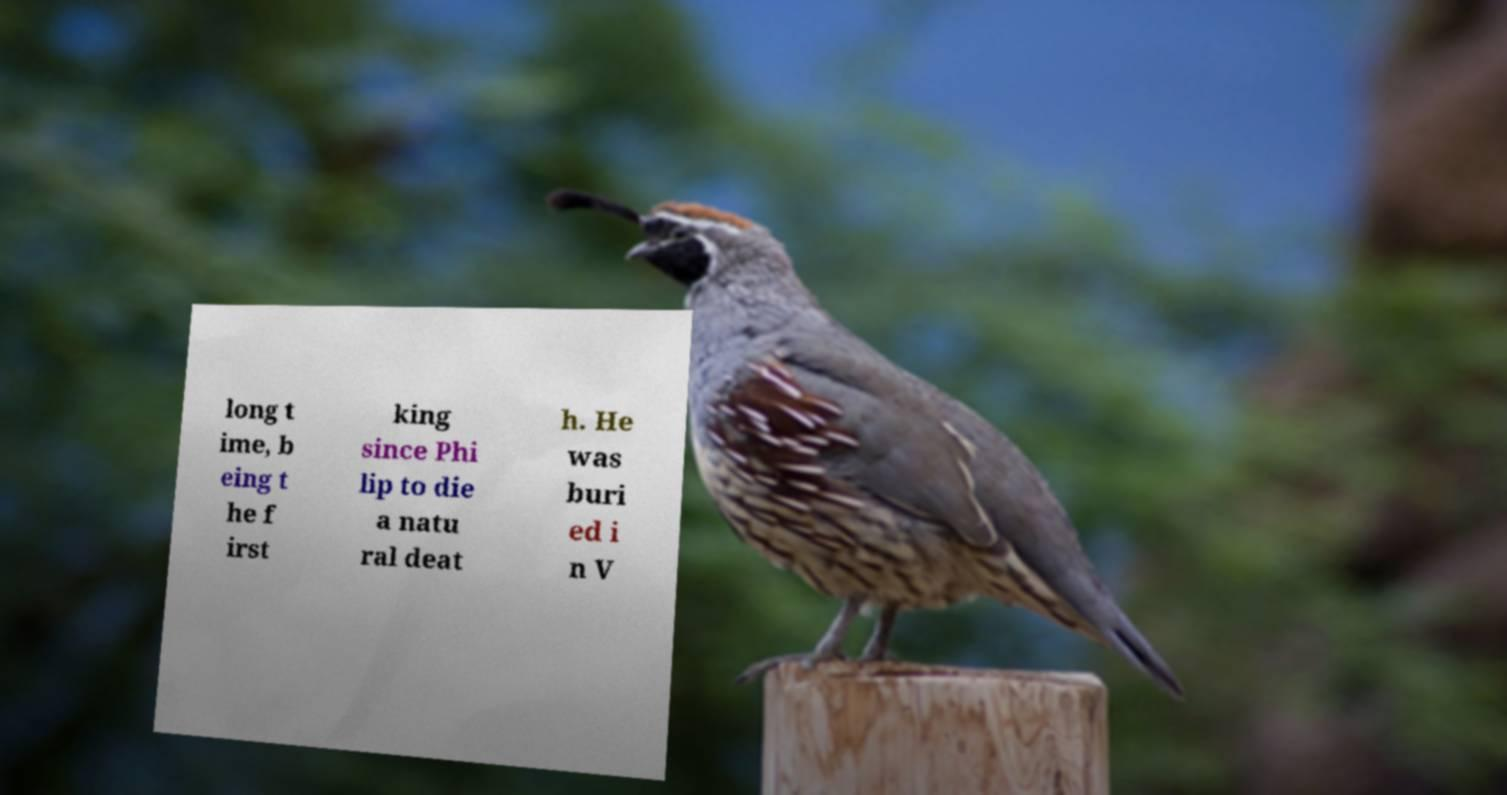Can you accurately transcribe the text from the provided image for me? long t ime, b eing t he f irst king since Phi lip to die a natu ral deat h. He was buri ed i n V 